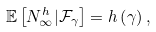<formula> <loc_0><loc_0><loc_500><loc_500>\mathbb { E } \left [ N _ { \infty } ^ { h } | \mathcal { F } _ { \gamma } \right ] = h \left ( \gamma \right ) ,</formula> 